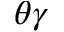Convert formula to latex. <formula><loc_0><loc_0><loc_500><loc_500>\theta \gamma</formula> 